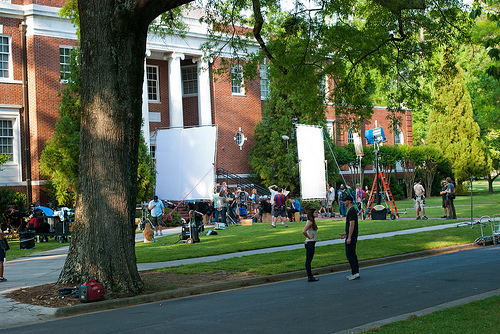<image>
Is there a street next to the screen? Yes. The street is positioned adjacent to the screen, located nearby in the same general area. 